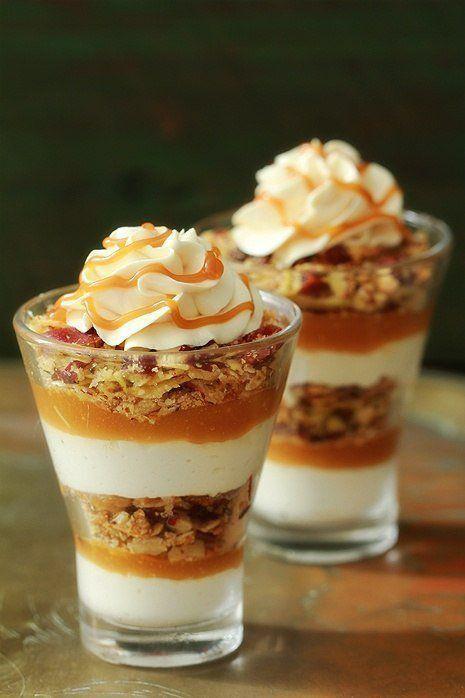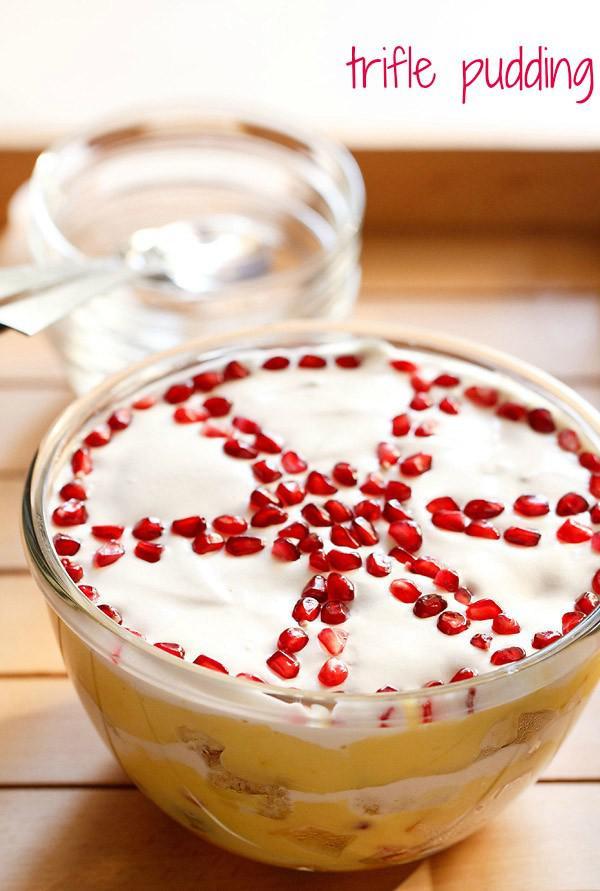The first image is the image on the left, the second image is the image on the right. Analyze the images presented: Is the assertion "A trifle is garnished with red fruit on white whipped cream." valid? Answer yes or no. Yes. 